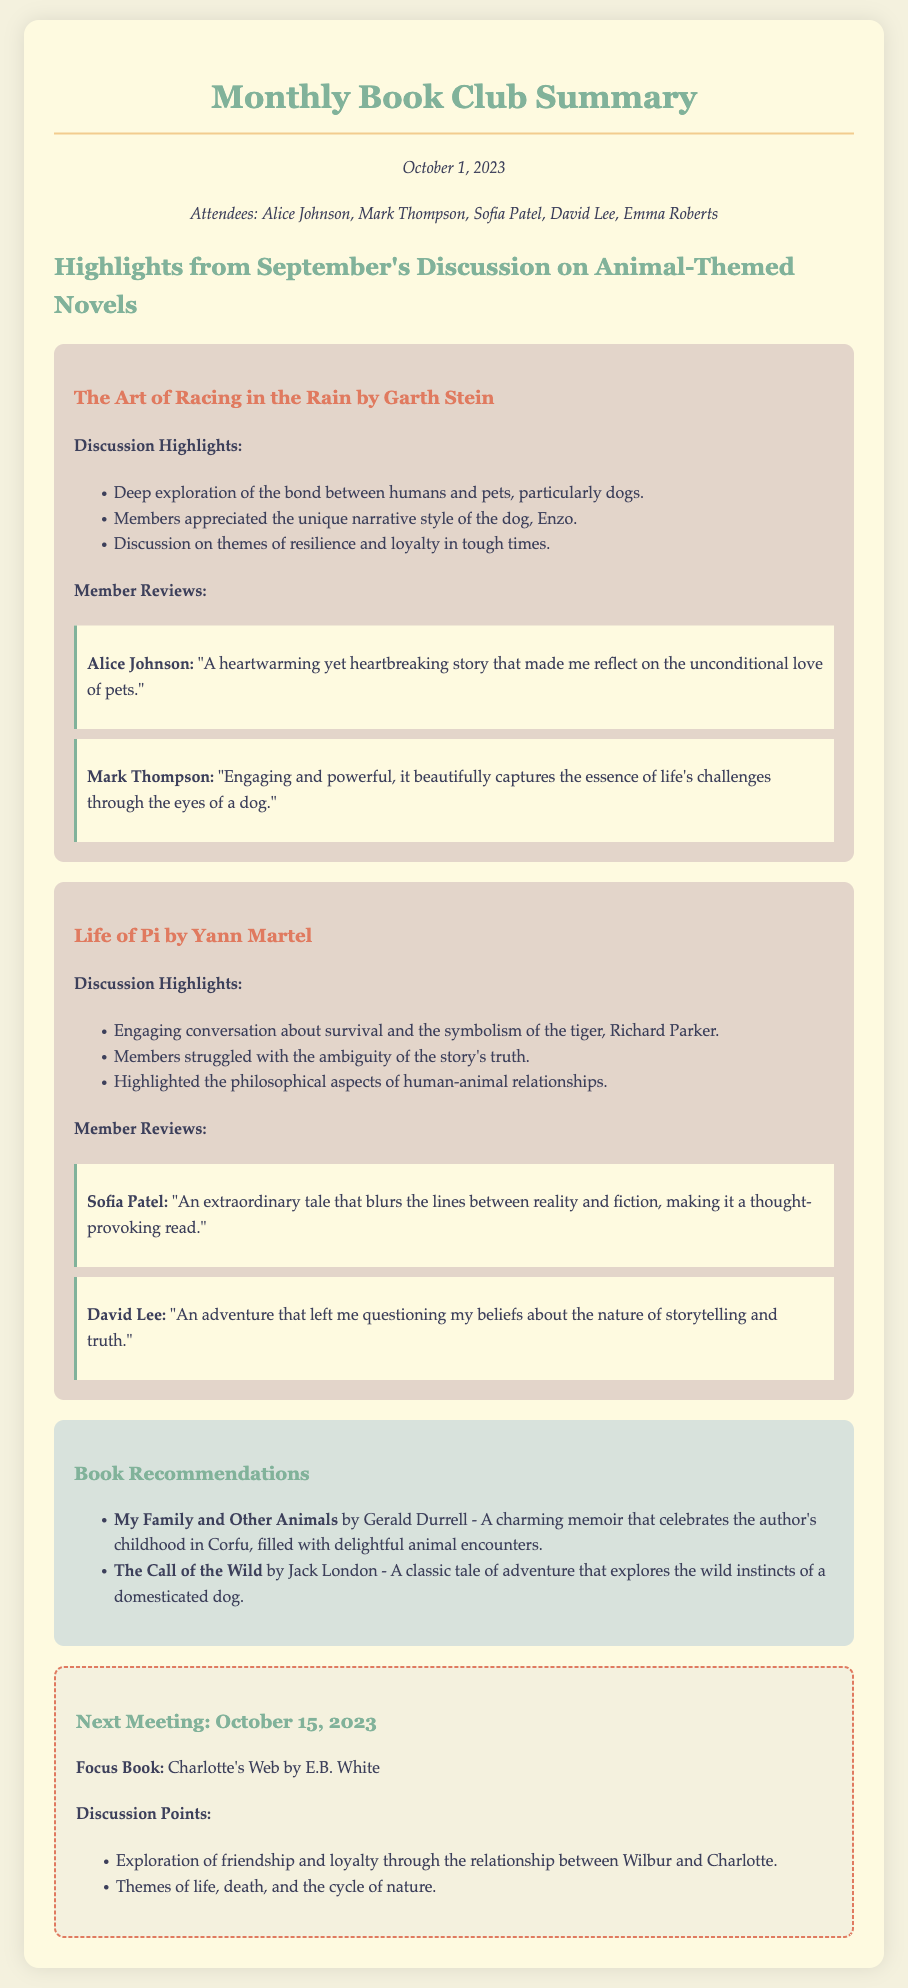What is the date of the meeting summary? The date is located at the top of the document, indicating when the summary was created.
Answer: October 1, 2023 Who is the author of "The Art of Racing in the Rain"? The author's name is cited in the section discussing this specific book, highlighting who wrote it.
Answer: Garth Stein Which member described "Life of Pi" as thought-provoking? This review is attributed to a specific member whose opinion is shared in the document regarding the book.
Answer: Sofia Patel What is the focus book for the next meeting? The focus book is mentioned at the end of the document under the next meeting section, clearly stating what will be read.
Answer: Charlotte's Web How many members attended the meeting? The number of attendees is listed in a specific section, providing the total count of participants.
Answer: Five What themes were discussed in relation to "The Art of Racing in the Rain"? The themes mentioned in the discussion highlights summarize what the book addresses, providing insight into the content.
Answer: Resilience and loyalty What type of book is "My Family and Other Animals"? The description provided includes information on the genre or nature of the book, clarifying its classification.
Answer: Memoir Which book was noted for exploring survival? The highlights section lists discussion points about various books, specifying their main themes and topics.
Answer: Life of Pi 